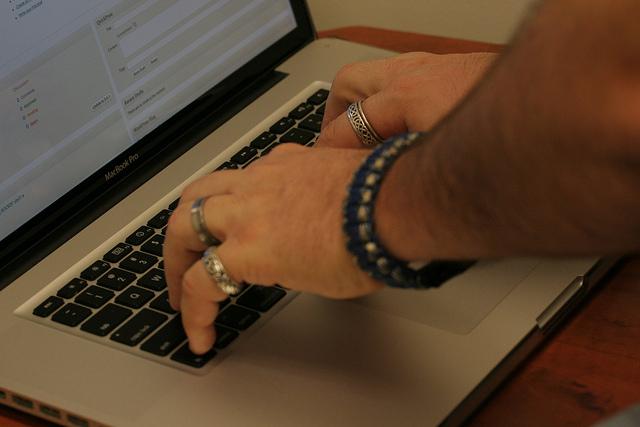How many rings do you see?
Quick response, please. 3. Is there a reflection?
Give a very brief answer. No. Is that a new computer?
Be succinct. Yes. What is the person wearing on his wrist?
Answer briefly. Bracelet. Is this a phone?
Short answer required. No. What is on top of the keyboard?
Give a very brief answer. Hands. What color is the wristband?
Concise answer only. Black. Is this a right or left hand?
Concise answer only. Left. What is on the keyboard?
Write a very short answer. Hands. Is the laptop open?
Be succinct. Yes. What color are the keys?
Short answer required. Black. Are those elbows on the table?
Keep it brief. No. Is this picture in color?
Short answer required. Yes. How many bracelets do you see?
Be succinct. 1. 